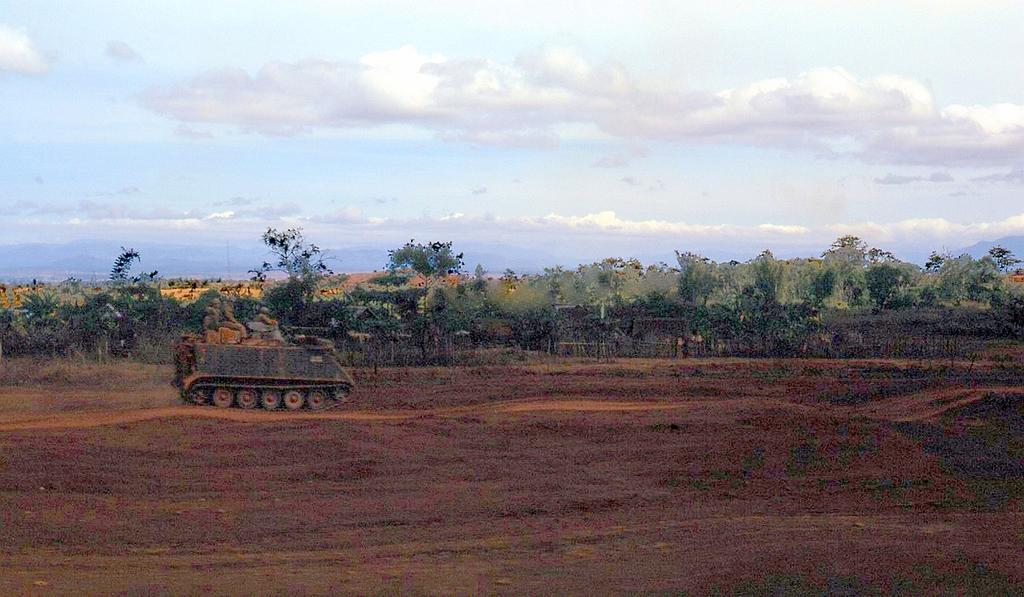What type of surface is visible in the image? There is a ground in the image. What color and type of vegetation can be seen in the image? There are green color plants in the image. What type of tall vegetation is present in the image? There are trees in the image. What is visible at the top of the image? The sky is visible at the top of the image. What can be seen in the sky in the image? There are white clouds in the sky. What type of skin is visible on the trees in the image? There is no mention of tree skin in the image; trees are typically covered in bark, not skin. 